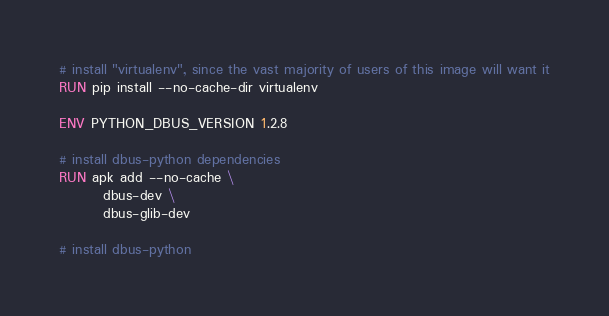<code> <loc_0><loc_0><loc_500><loc_500><_Dockerfile_>
# install "virtualenv", since the vast majority of users of this image will want it
RUN pip install --no-cache-dir virtualenv

ENV PYTHON_DBUS_VERSION 1.2.8

# install dbus-python dependencies 
RUN apk add --no-cache \
		dbus-dev \
		dbus-glib-dev

# install dbus-python</code> 